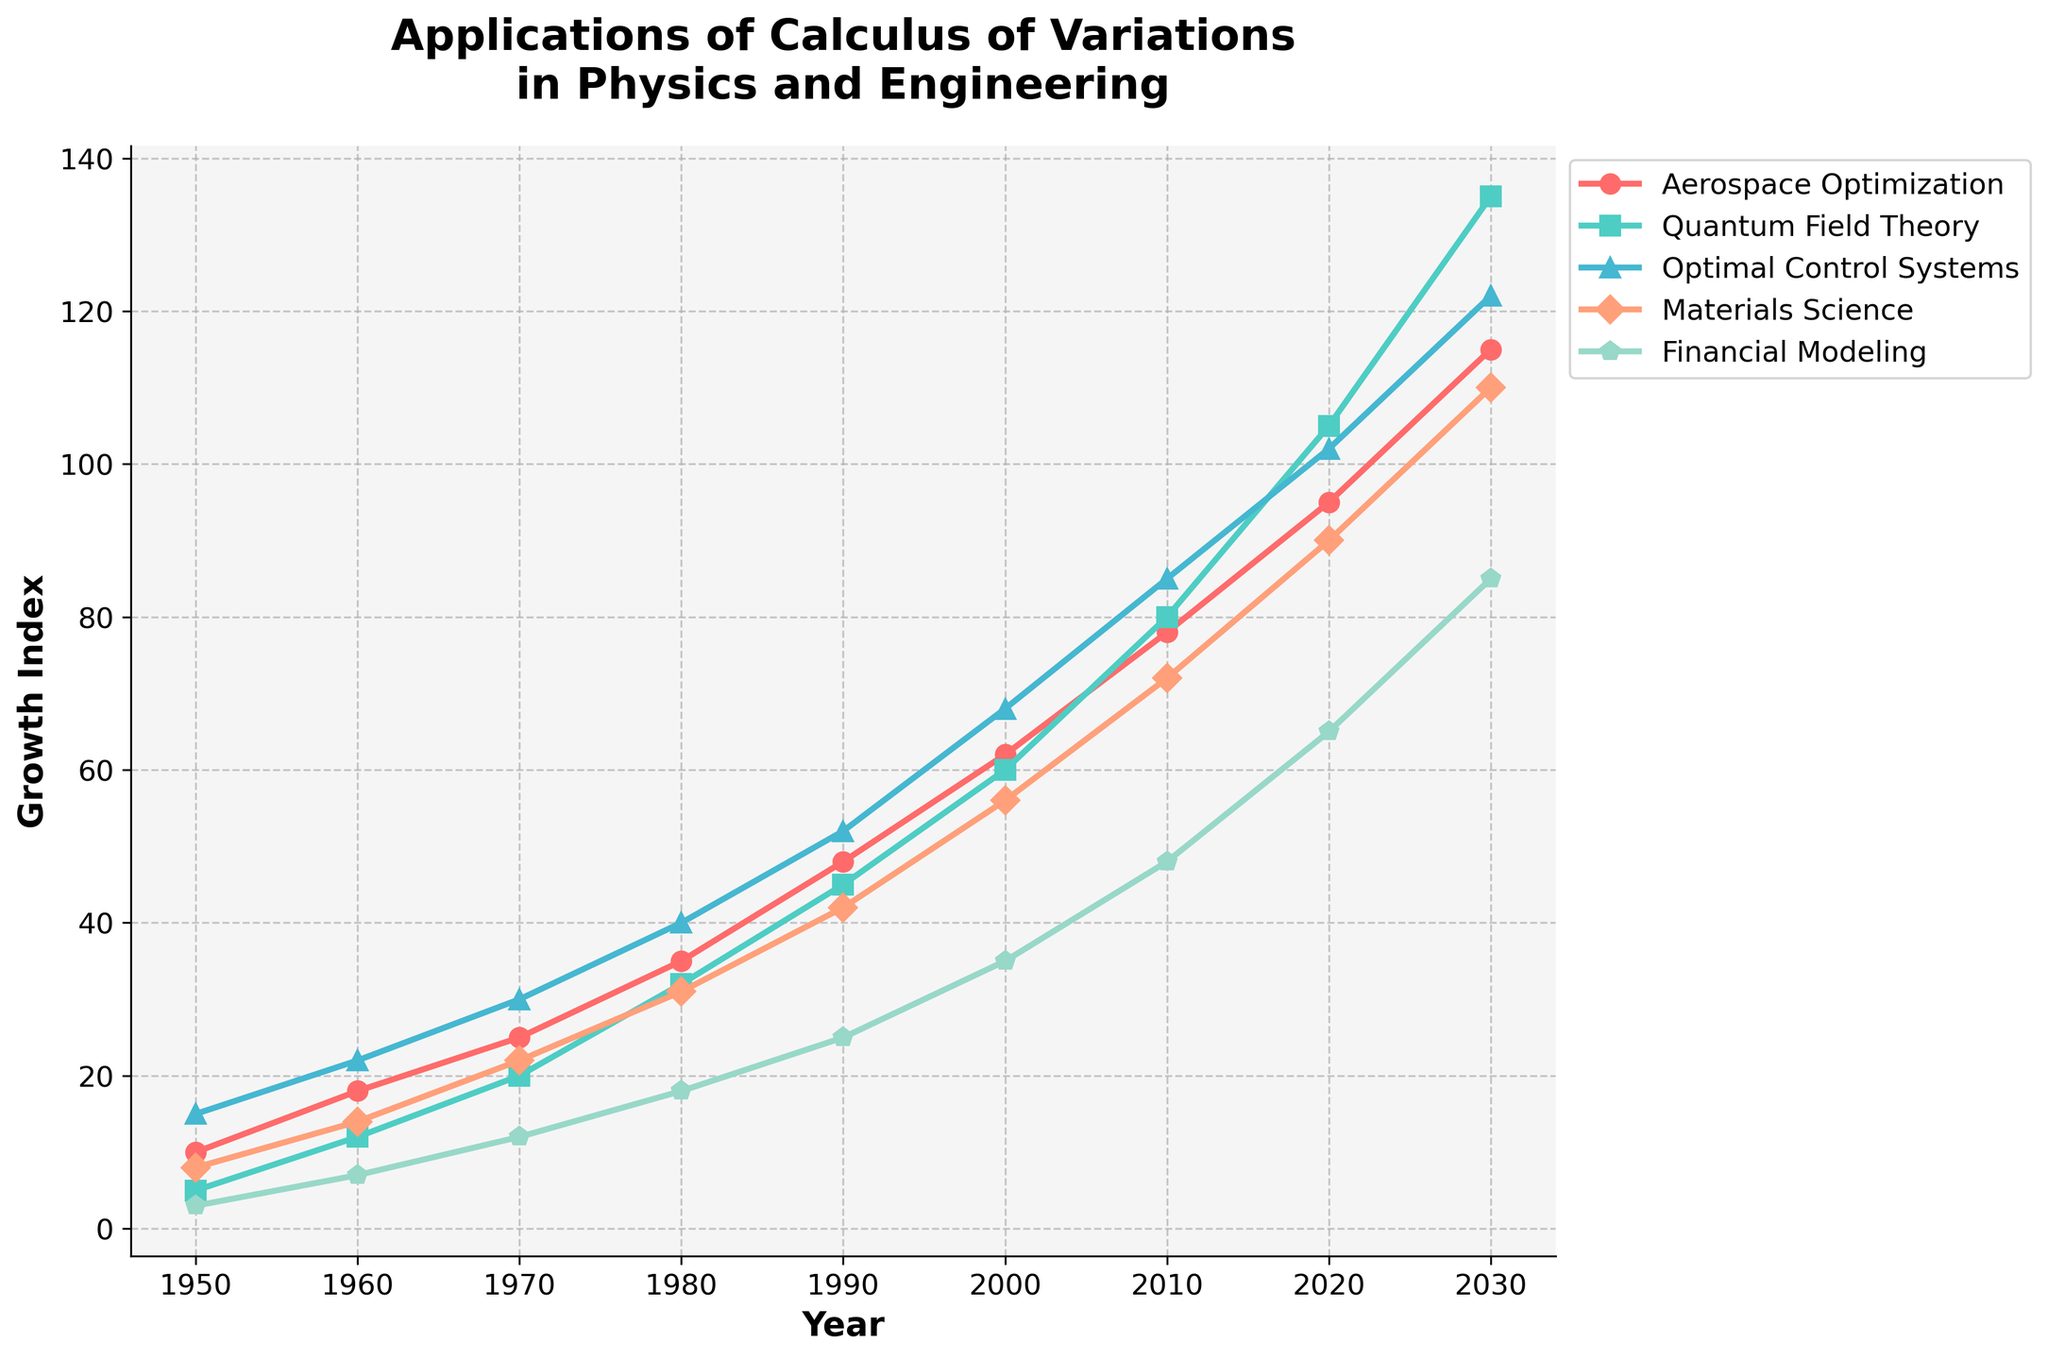Which sector had the highest growth index in 2020? Look for the sector with the highest point in 2020 on the graph and compare the values. The sector with the highest point is Quantum Field Theory.
Answer: Quantum Field Theory What is the difference in growth index between Aerospace Optimization and Materials Science in 2030? Identify the growth indices for Aerospace Optimization and Materials Science in 2030 from the graph. Aerospace Optimization is at 115 and Materials Science is at 110. Subtract the smaller value from the larger value: 115 - 110 = 5.
Answer: 5 Which sector showed the most consistent growth trend from 1950 to 2030? Visually examine the lines representing each sector from 1950 to 2030 and identify which has the least fluctuations and a consistent upward trend. Aerospace Optimization shows the most consistent growth.
Answer: Aerospace Optimization Compare the growth indices of Financial Modeling and Optimal Control Systems in 1990. Which one is greater, and by how much? Locate the points for Financial Modeling and Optimal Control Systems in 1990. Financial Modeling is at 25, and Optimal Control Systems is at 52. Subtract 25 from 52 to find the difference: 52 - 25 = 27.
Answer: Optimal Control Systems, 27 Calculate the average growth index for Quantum Field Theory from 1950 to 2030. List the values for Quantum Field Theory: 5, 12, 20, 32, 45, 60, 80, 105, 135. Sum the values: 5 + 12 + 20 + 32 + 45 + 60 + 80 + 105 + 135 = 494. Divide by the number of years (9): 494 / 9 = ~54.89.
Answer: 54.89 How does the trend of Financial Modeling compare with the trend of Materials Science over the period of 1950 to 2030? Examine the lines for both Financial Modeling and Materials Science from 1950 to 2030. Financial Modeling shows a gradual upward trend, while Materials Science also shows an upward trend but with larger increments.
Answer: Both show upward trends, but Materials Science grows faster In which decade did Optimal Control Systems see the highest increase in growth index? Observe the increments in the Optimal Control Systems line for each decade. The highest increase occurs between 2000 and 2010, where it jumps from 68 to 85, an increase of 17.
Answer: 2000 to 2010 What color represents the Quantum Field Theory sector in the chart? Look at the legend to match the sector name with its corresponding color. Quantum Field Theory is represented by the green color.
Answer: Green Which sector had the slowest growth between 2010 and 2020? Compare the growth increments for each sector between 2010 and 2020. The slowest growth is in Financial Modeling, which grows from 48 to 65, an increment of 17.
Answer: Financial Modeling If the current trend continues, which sector is predicted to have the highest growth index in 2030? Extend the lines based on their current slopes visually. Quantum Field Theory's line is the highest in 2020 and continues to rise steeply.
Answer: Quantum Field Theory 